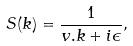<formula> <loc_0><loc_0><loc_500><loc_500>S ( k ) = \frac { 1 } { v . k + i \epsilon } ,</formula> 